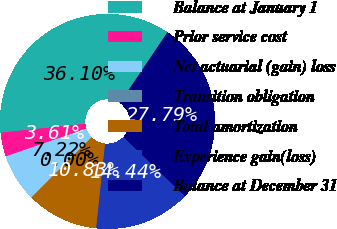Convert chart. <chart><loc_0><loc_0><loc_500><loc_500><pie_chart><fcel>Balance at January 1<fcel>Prior service cost<fcel>Net actuarial (gain) loss<fcel>Transition obligation<fcel>Total amortization<fcel>Experience gain(loss)<fcel>Balance at December 31<nl><fcel>36.1%<fcel>3.61%<fcel>7.22%<fcel>0.0%<fcel>10.83%<fcel>14.44%<fcel>27.79%<nl></chart> 